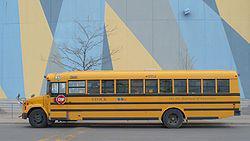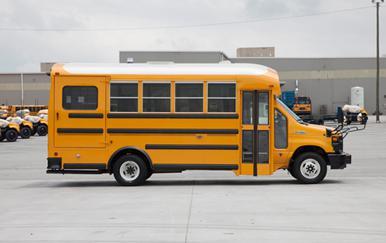The first image is the image on the left, the second image is the image on the right. For the images displayed, is the sentence "A bus is in the sun." factually correct? Answer yes or no. No. The first image is the image on the left, the second image is the image on the right. Examine the images to the left and right. Is the description "The buses in the left and right images are displayed horizontally and back-to-back." accurate? Answer yes or no. Yes. 